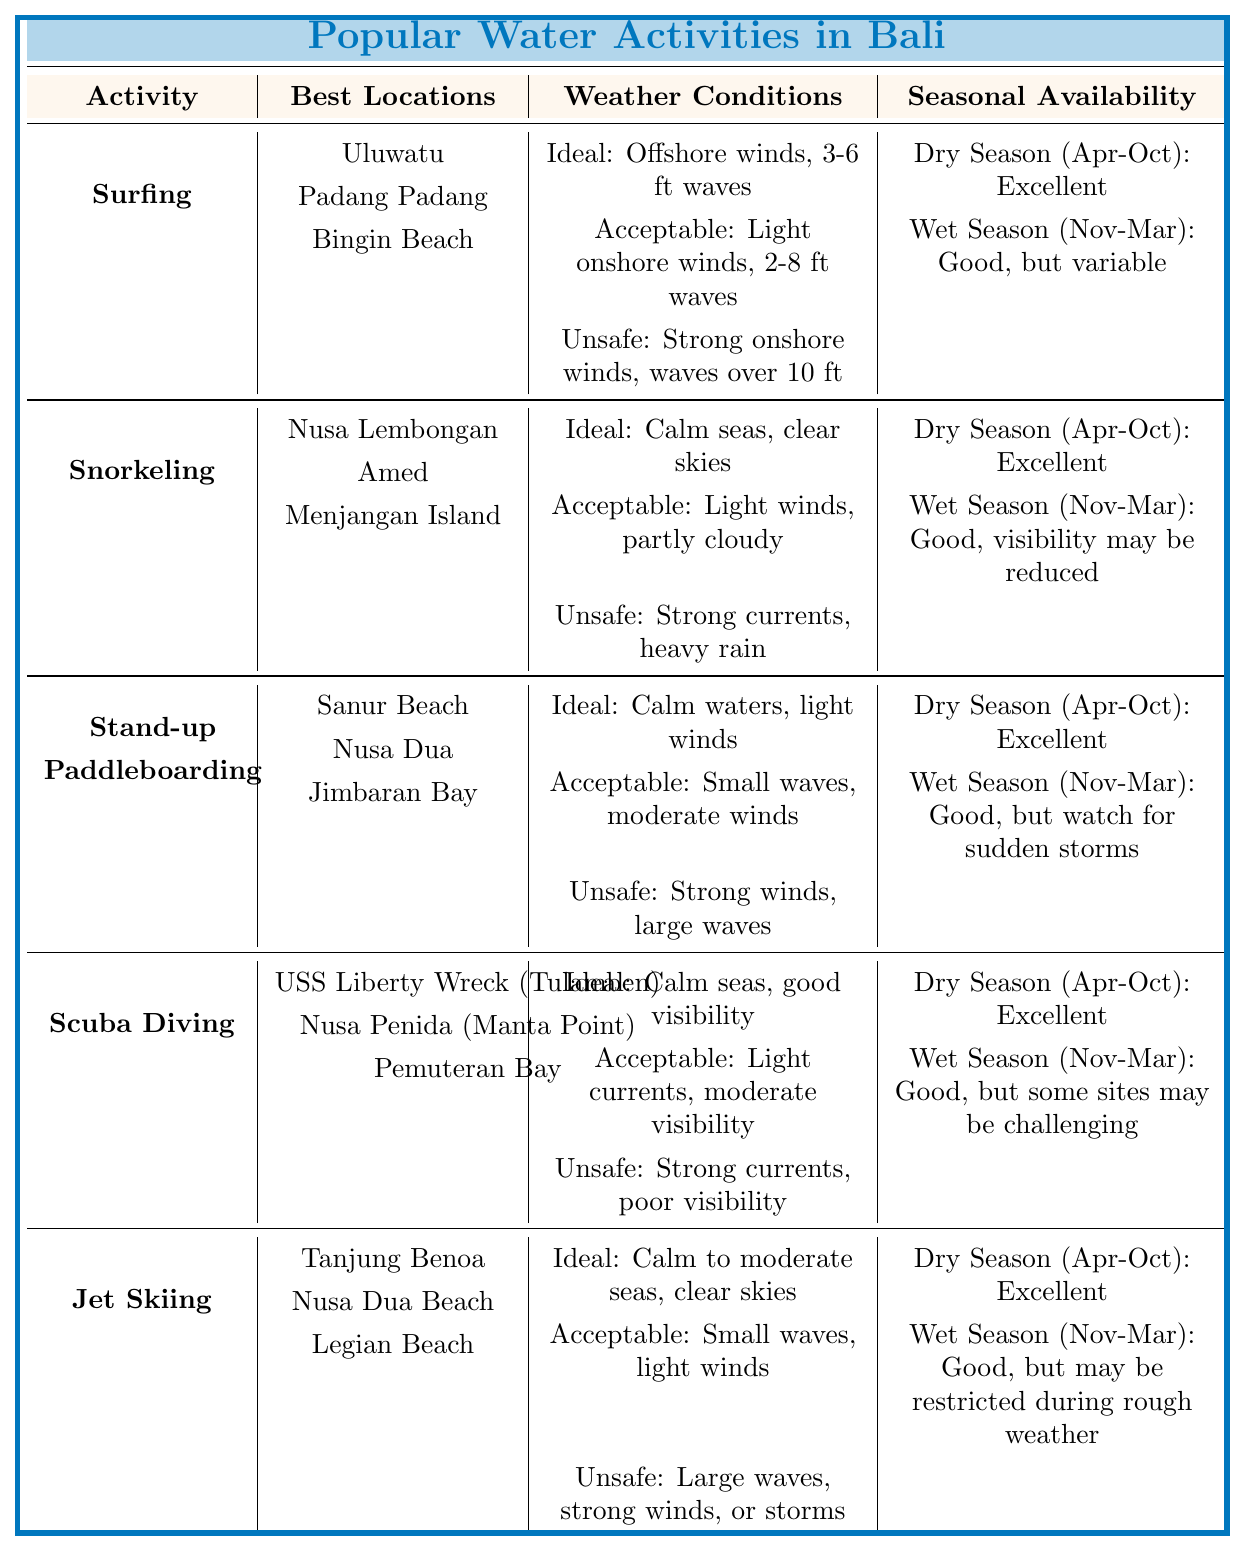What are the ideal weather conditions for snorkeling? The table lists the ideal weather conditions for snorkeling as "Calm seas, clear skies" under the snorkeling activity.
Answer: Calm seas, clear skies Which water activity has the least favorable availability during the wet season? According to the table, all activities have "Good" availability during the wet season, but some mention variability or challenges, specifically surfing and jet skiing, which are noted as "Good, but variable" and "Good, but may be restricted during rough weather" respectively. Surfing may be considered less favorable due to variability in conditions.
Answer: Surfing True or False: Jet Skiing is unsafe under calm seas. The table lists the unsafe conditions for jet skiing as "Large waves, strong winds, or storms," indicating that calm seas are not unsafe for the activity. Therefore, the statement is false.
Answer: False For which activity is visibility a concern during the wet season? The table indicates that for scuba diving, the seasonal availability during the wet season is "Good, but some sites may be challenging," implying visibility concerns.
Answer: Scuba Diving What are the best locations for stand-up paddleboarding? The table lists the best locations for stand-up paddleboarding as "Sanur Beach, Nusa Dua, Jimbaran Bay."
Answer: Sanur Beach, Nusa Dua, Jimbaran Bay Which two activities have excellent seasonal availability in the dry season? Both surfing and snorkeling are marked as having "Excellent" availability during the dry season in the table.
Answer: Surfing, Snorkeling What is the acceptable weather condition for surfing? The table states that the acceptable weather condition for surfing is "Light onshore winds, 2-8 ft waves."
Answer: Light onshore winds, 2-8 ft waves If I want to go scuba diving during the wet season, what should I expect? The table indicates that during the wet season, scuba diving has "Good, but some sites may be challenging" availability, which means that while it's possible, some locations might encounter difficulties.
Answer: Good, but some sites may be challenging How many activities listed have their ideal conditions involving calm seas? The activities that specify "Calm seas" in the ideal weather conditions are snorkeling and scuba diving. Therefore, there are two activities.
Answer: 2 What is the ideal condition for jet skiing? According to the table, the ideal condition for jet skiing is "Calm to moderate seas, clear skies."
Answer: Calm to moderate seas, clear skies 